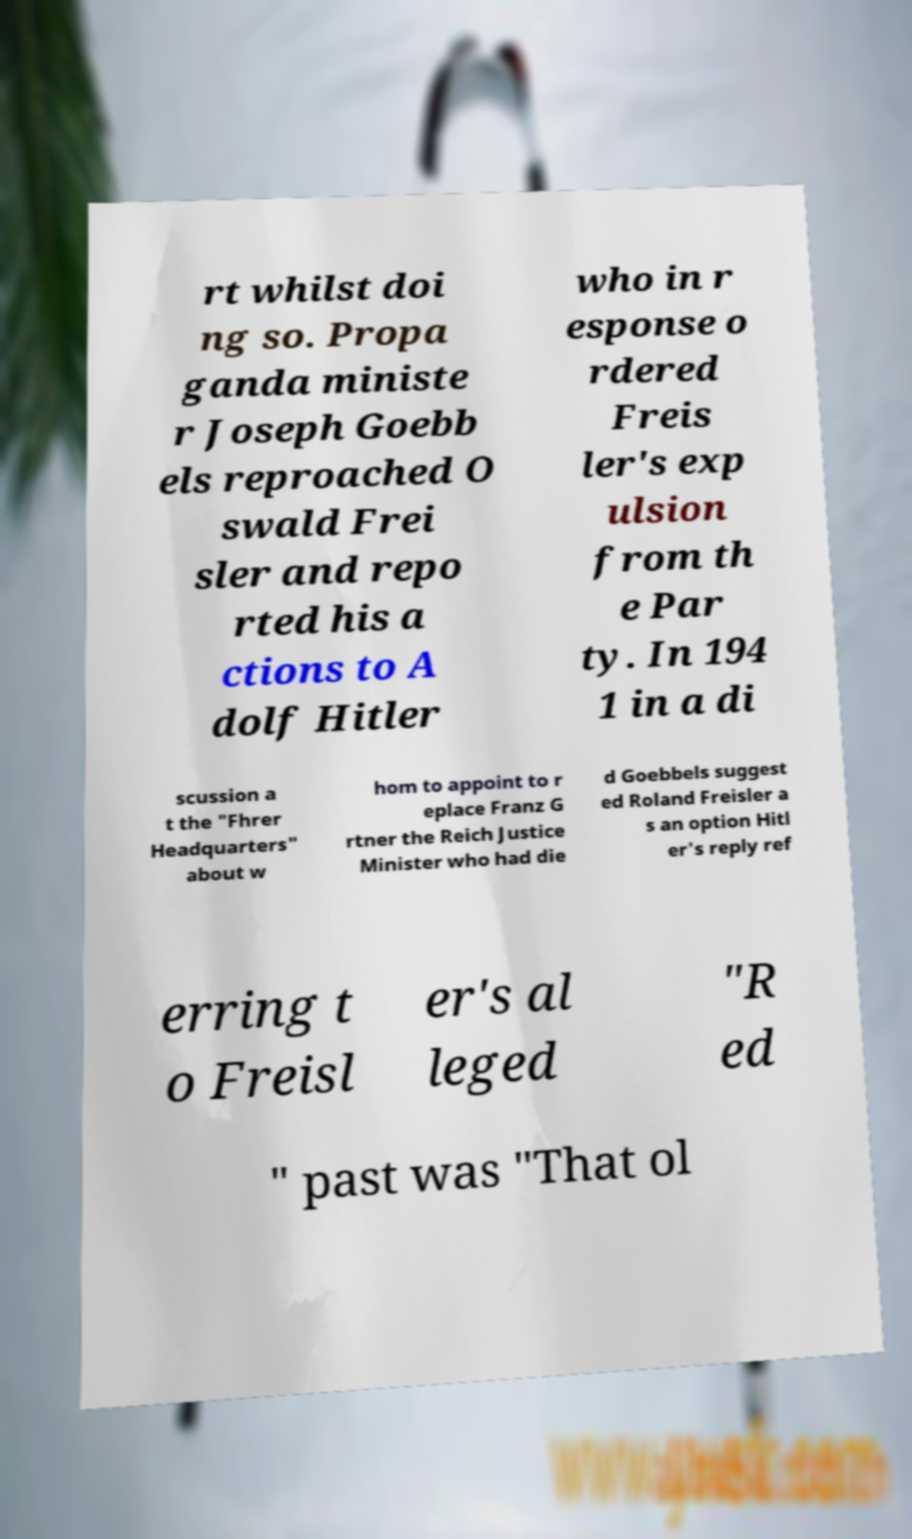Can you accurately transcribe the text from the provided image for me? rt whilst doi ng so. Propa ganda ministe r Joseph Goebb els reproached O swald Frei sler and repo rted his a ctions to A dolf Hitler who in r esponse o rdered Freis ler's exp ulsion from th e Par ty. In 194 1 in a di scussion a t the "Fhrer Headquarters" about w hom to appoint to r eplace Franz G rtner the Reich Justice Minister who had die d Goebbels suggest ed Roland Freisler a s an option Hitl er's reply ref erring t o Freisl er's al leged "R ed " past was "That ol 